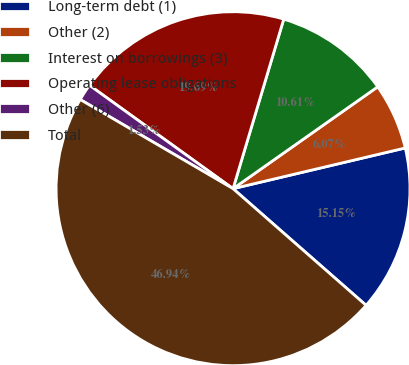<chart> <loc_0><loc_0><loc_500><loc_500><pie_chart><fcel>Long-term debt (1)<fcel>Other (2)<fcel>Interest on borrowings (3)<fcel>Operating lease obligations<fcel>Other (6)<fcel>Total<nl><fcel>15.15%<fcel>6.07%<fcel>10.61%<fcel>19.69%<fcel>1.53%<fcel>46.94%<nl></chart> 